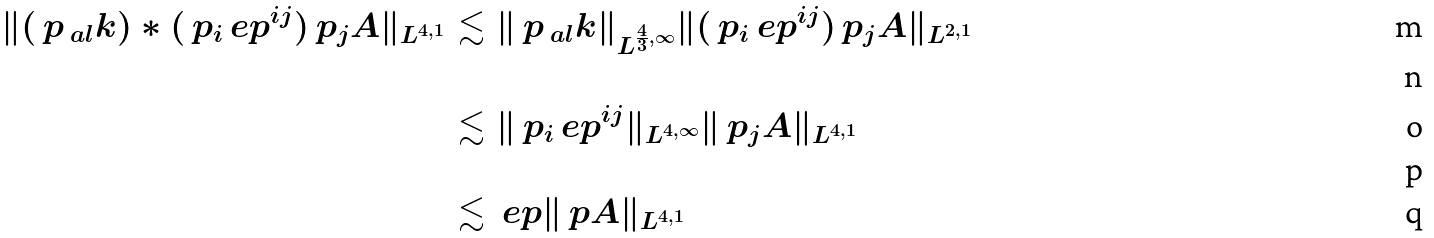<formula> <loc_0><loc_0><loc_500><loc_500>\| ( \ p _ { \ a l } k ) \ast ( \ p _ { i } \ e p ^ { i j } ) \ p _ { j } A \| _ { L ^ { 4 , 1 } } & \lesssim \| \ p _ { \ a l } k \| _ { L ^ { \frac { 4 } { 3 } , \infty } } \| ( \ p _ { i } \ e p ^ { i j } ) \ p _ { j } A \| _ { L ^ { 2 , 1 } } \\ \\ & \lesssim \| \ p _ { i } \ e p ^ { i j } \| _ { L ^ { 4 , \infty } } \| \ p _ { j } A \| _ { L ^ { 4 , 1 } } \\ \\ & \lesssim \ e p \| \ p A \| _ { L ^ { 4 , 1 } }</formula> 